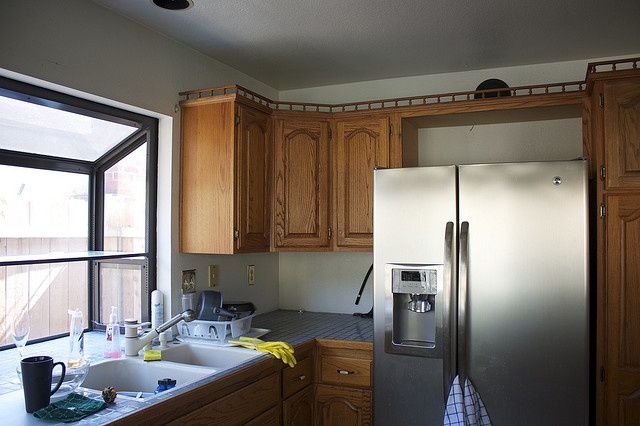Describe the objects in this image and their specific colors. I can see refrigerator in black, ivory, gray, and darkgray tones, sink in black, darkgray, and gray tones, cup in black, navy, lavender, and gray tones, bowl in black, lavender, darkgray, gray, and lightblue tones, and wine glass in black, lightgray, darkgray, and lightblue tones in this image. 